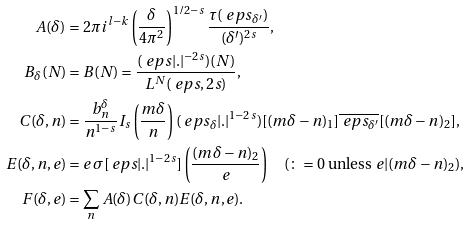<formula> <loc_0><loc_0><loc_500><loc_500>A ( \delta ) & = 2 \pi i ^ { l - k } \left ( \frac { \delta } { 4 \pi ^ { 2 } } \right ) ^ { 1 / 2 - s } \frac { \tau ( \ e p s _ { \delta ^ { \prime } } ) } { ( \delta ^ { \prime } ) ^ { 2 s } } , \\ B _ { \delta } ( N ) & = B ( N ) = \frac { ( \ e p s | . | ^ { - 2 s } ) ( N ) } { L ^ { N } ( \ e p s , 2 s ) } , \\ C ( \delta , n ) & = \frac { b _ { n } ^ { \delta } } { n ^ { 1 - s } } I _ { s } \left ( \frac { m \delta } { n } \right ) ( \ e p s _ { \delta } | . | ^ { 1 - 2 s } ) [ ( m \delta - n ) _ { 1 } ] \overline { \ e p s _ { \delta ^ { \prime } } } [ ( m \delta - n ) _ { 2 } ] , \\ E ( \delta , n , e ) & = e \, \sigma [ { \ e p s | . | ^ { 1 - 2 s } } ] \left ( \frac { ( m \delta - n ) _ { 2 } } { e } \right ) \quad ( \colon = 0 \text { unless } e | ( m \delta - n ) _ { 2 } ) , \\ F ( \delta , e ) & = \sum _ { n } A ( \delta ) C ( \delta , n ) E ( \delta , n , e ) .</formula> 